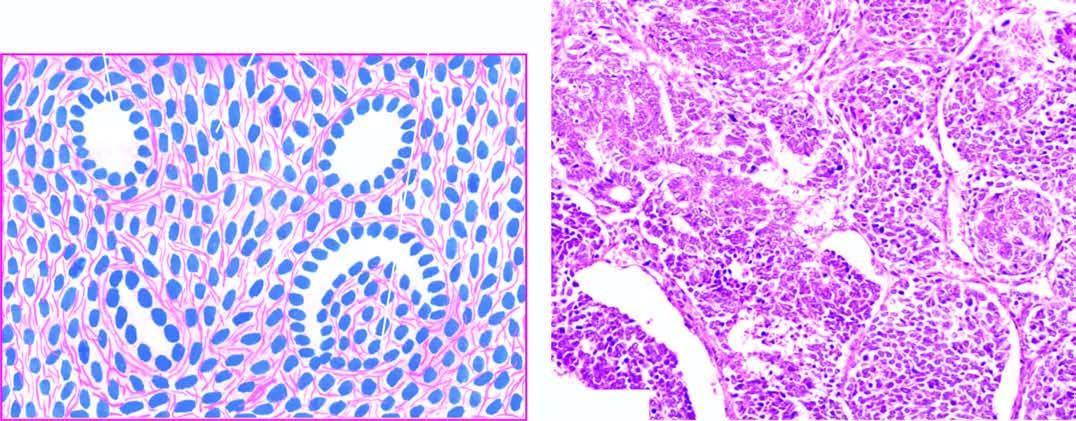s diagrammatic representation of pathologic changes in chronic hepatitis present in it?
Answer the question using a single word or phrase. No 